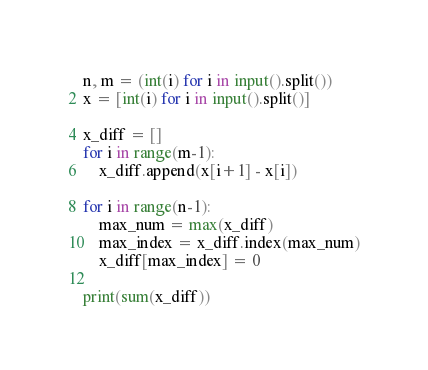<code> <loc_0><loc_0><loc_500><loc_500><_Python_>n, m = (int(i) for i in input().split())  
x = [int(i) for i in input().split()]  

x_diff = []
for i in range(m-1):
    x_diff.append(x[i+1] - x[i])

for i in range(n-1):
    max_num = max(x_diff)
    max_index = x_diff.index(max_num)
    x_diff[max_index] = 0

print(sum(x_diff))</code> 